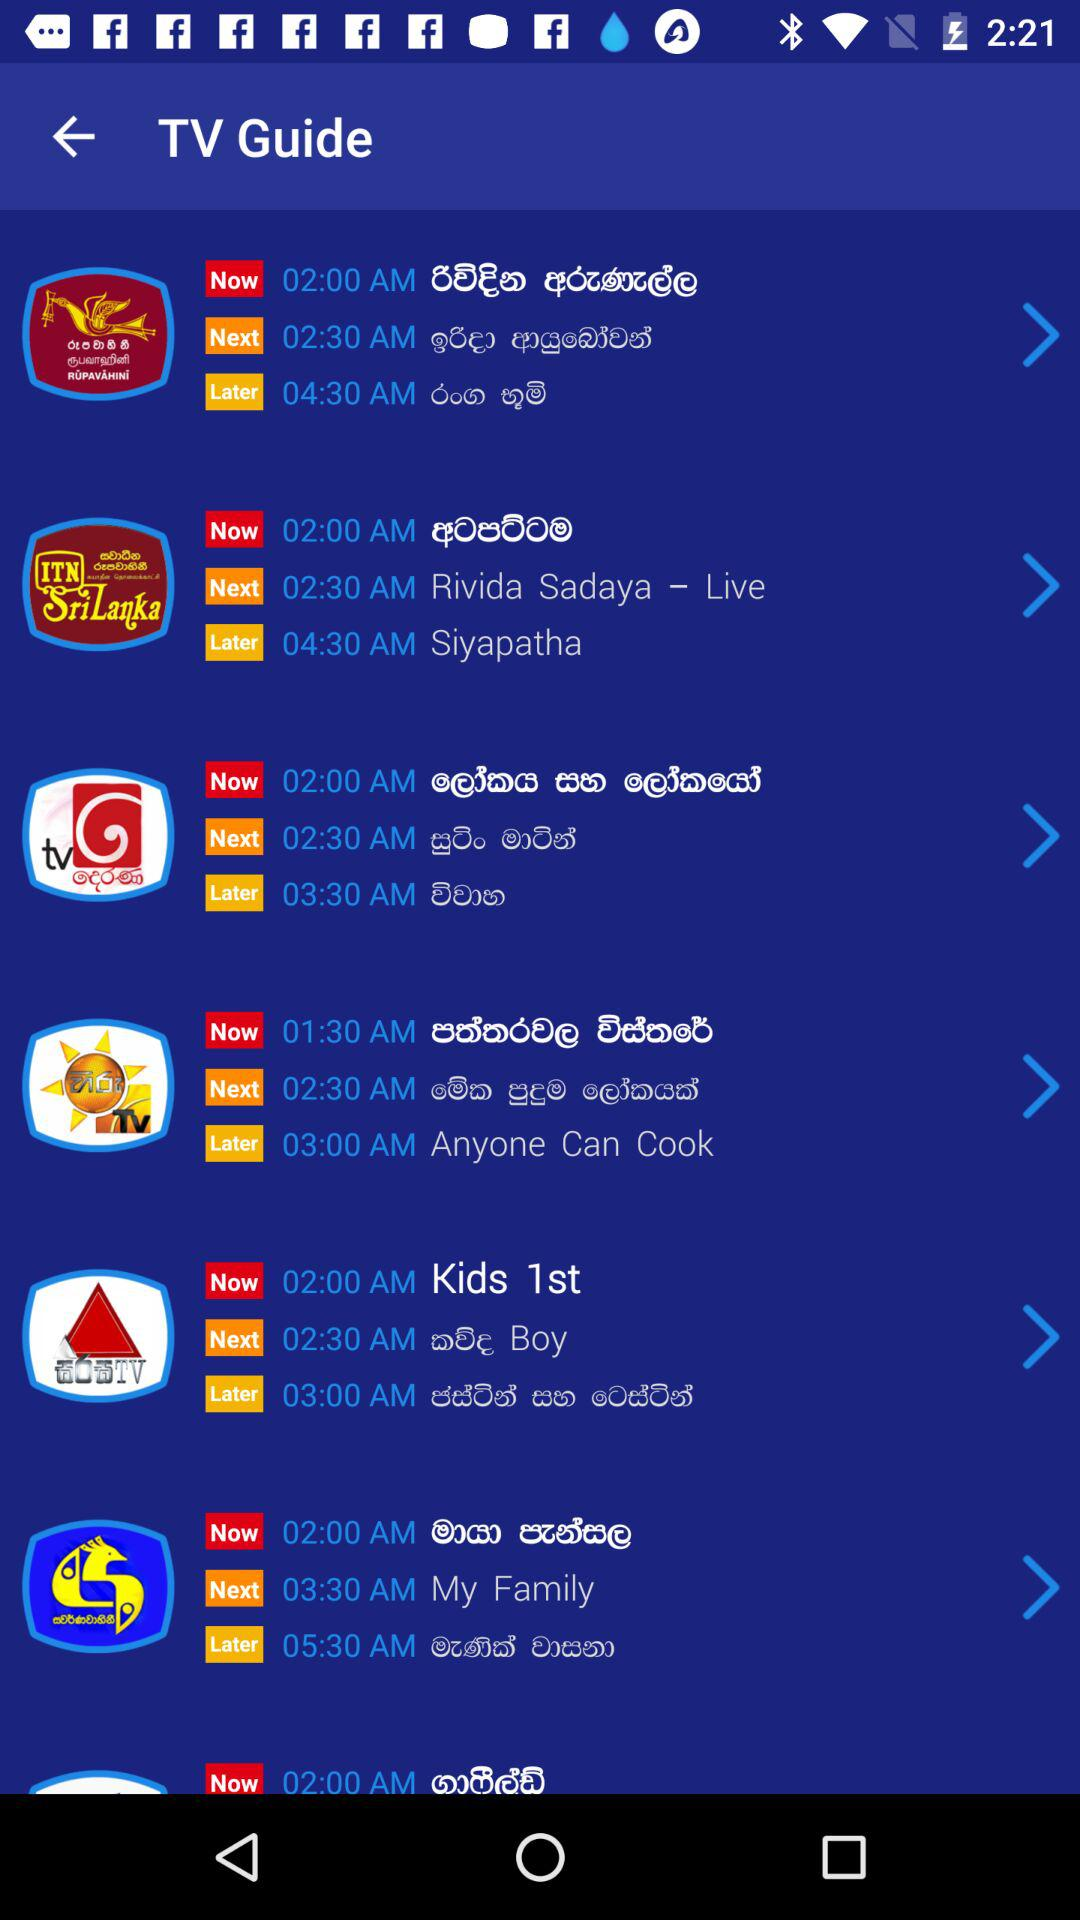What is the app name?
When the provided information is insufficient, respond with <no answer>. <no answer> 